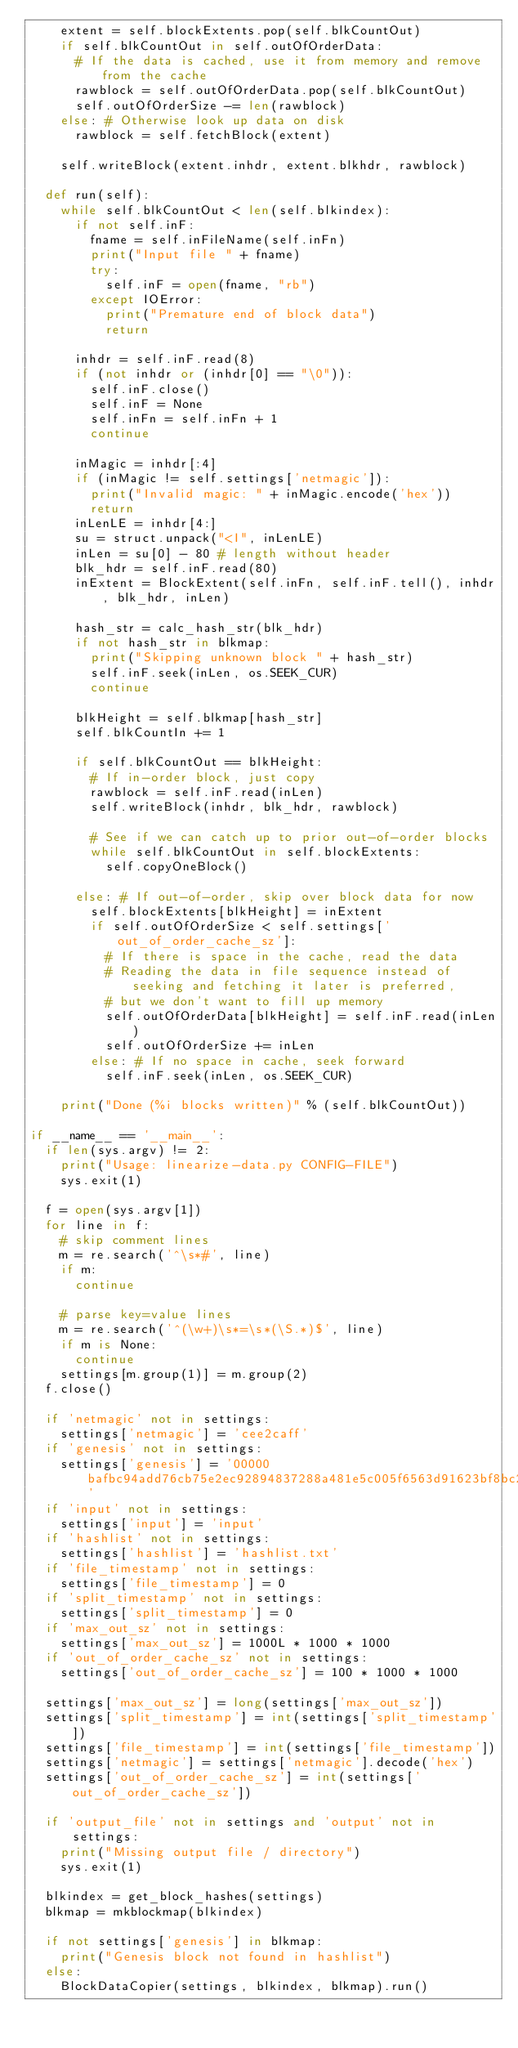Convert code to text. <code><loc_0><loc_0><loc_500><loc_500><_Python_>		extent = self.blockExtents.pop(self.blkCountOut)
		if self.blkCountOut in self.outOfOrderData:
			# If the data is cached, use it from memory and remove from the cache
			rawblock = self.outOfOrderData.pop(self.blkCountOut)
			self.outOfOrderSize -= len(rawblock)
		else: # Otherwise look up data on disk
			rawblock = self.fetchBlock(extent)

		self.writeBlock(extent.inhdr, extent.blkhdr, rawblock)

	def run(self):
		while self.blkCountOut < len(self.blkindex):
			if not self.inF:
				fname = self.inFileName(self.inFn)
				print("Input file " + fname)
				try:
					self.inF = open(fname, "rb")
				except IOError:
					print("Premature end of block data")
					return

			inhdr = self.inF.read(8)
			if (not inhdr or (inhdr[0] == "\0")):
				self.inF.close()
				self.inF = None
				self.inFn = self.inFn + 1
				continue

			inMagic = inhdr[:4]
			if (inMagic != self.settings['netmagic']):
				print("Invalid magic: " + inMagic.encode('hex'))
				return
			inLenLE = inhdr[4:]
			su = struct.unpack("<I", inLenLE)
			inLen = su[0] - 80 # length without header
			blk_hdr = self.inF.read(80)
			inExtent = BlockExtent(self.inFn, self.inF.tell(), inhdr, blk_hdr, inLen)

			hash_str = calc_hash_str(blk_hdr)
			if not hash_str in blkmap:
				print("Skipping unknown block " + hash_str)
				self.inF.seek(inLen, os.SEEK_CUR)
				continue

			blkHeight = self.blkmap[hash_str]
			self.blkCountIn += 1

			if self.blkCountOut == blkHeight:
				# If in-order block, just copy
				rawblock = self.inF.read(inLen)
				self.writeBlock(inhdr, blk_hdr, rawblock)

				# See if we can catch up to prior out-of-order blocks
				while self.blkCountOut in self.blockExtents:
					self.copyOneBlock()

			else: # If out-of-order, skip over block data for now
				self.blockExtents[blkHeight] = inExtent
				if self.outOfOrderSize < self.settings['out_of_order_cache_sz']:
					# If there is space in the cache, read the data
					# Reading the data in file sequence instead of seeking and fetching it later is preferred,
					# but we don't want to fill up memory
					self.outOfOrderData[blkHeight] = self.inF.read(inLen)
					self.outOfOrderSize += inLen
				else: # If no space in cache, seek forward
					self.inF.seek(inLen, os.SEEK_CUR)

		print("Done (%i blocks written)" % (self.blkCountOut))

if __name__ == '__main__':
	if len(sys.argv) != 2:
		print("Usage: linearize-data.py CONFIG-FILE")
		sys.exit(1)

	f = open(sys.argv[1])
	for line in f:
		# skip comment lines
		m = re.search('^\s*#', line)
		if m:
			continue

		# parse key=value lines
		m = re.search('^(\w+)\s*=\s*(\S.*)$', line)
		if m is None:
			continue
		settings[m.group(1)] = m.group(2)
	f.close()

	if 'netmagic' not in settings:
		settings['netmagic'] = 'cee2caff'
	if 'genesis' not in settings:
		settings['genesis'] = '00000bafbc94add76cb75e2ec92894837288a481e5c005f6563d91623bf8bc2c'
	if 'input' not in settings:
		settings['input'] = 'input'
	if 'hashlist' not in settings:
		settings['hashlist'] = 'hashlist.txt'
	if 'file_timestamp' not in settings:
		settings['file_timestamp'] = 0
	if 'split_timestamp' not in settings:
		settings['split_timestamp'] = 0
	if 'max_out_sz' not in settings:
		settings['max_out_sz'] = 1000L * 1000 * 1000
	if 'out_of_order_cache_sz' not in settings:
		settings['out_of_order_cache_sz'] = 100 * 1000 * 1000

	settings['max_out_sz'] = long(settings['max_out_sz'])
	settings['split_timestamp'] = int(settings['split_timestamp'])
	settings['file_timestamp'] = int(settings['file_timestamp'])
	settings['netmagic'] = settings['netmagic'].decode('hex')
	settings['out_of_order_cache_sz'] = int(settings['out_of_order_cache_sz'])

	if 'output_file' not in settings and 'output' not in settings:
		print("Missing output file / directory")
		sys.exit(1)

	blkindex = get_block_hashes(settings)
	blkmap = mkblockmap(blkindex)

	if not settings['genesis'] in blkmap:
		print("Genesis block not found in hashlist")
	else:
		BlockDataCopier(settings, blkindex, blkmap).run()

</code> 